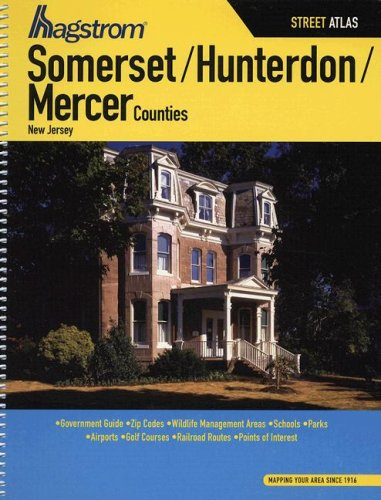What can you tell about the architectural style of the building shown on the cover of this atlas? The building on the cover exhibits characteristics typical of Victorian architecture, noted for its elaborate detailing, asymmetrical shape, and spacious porch areas, which add to the aesthetic appeal of this region's residential properties. 